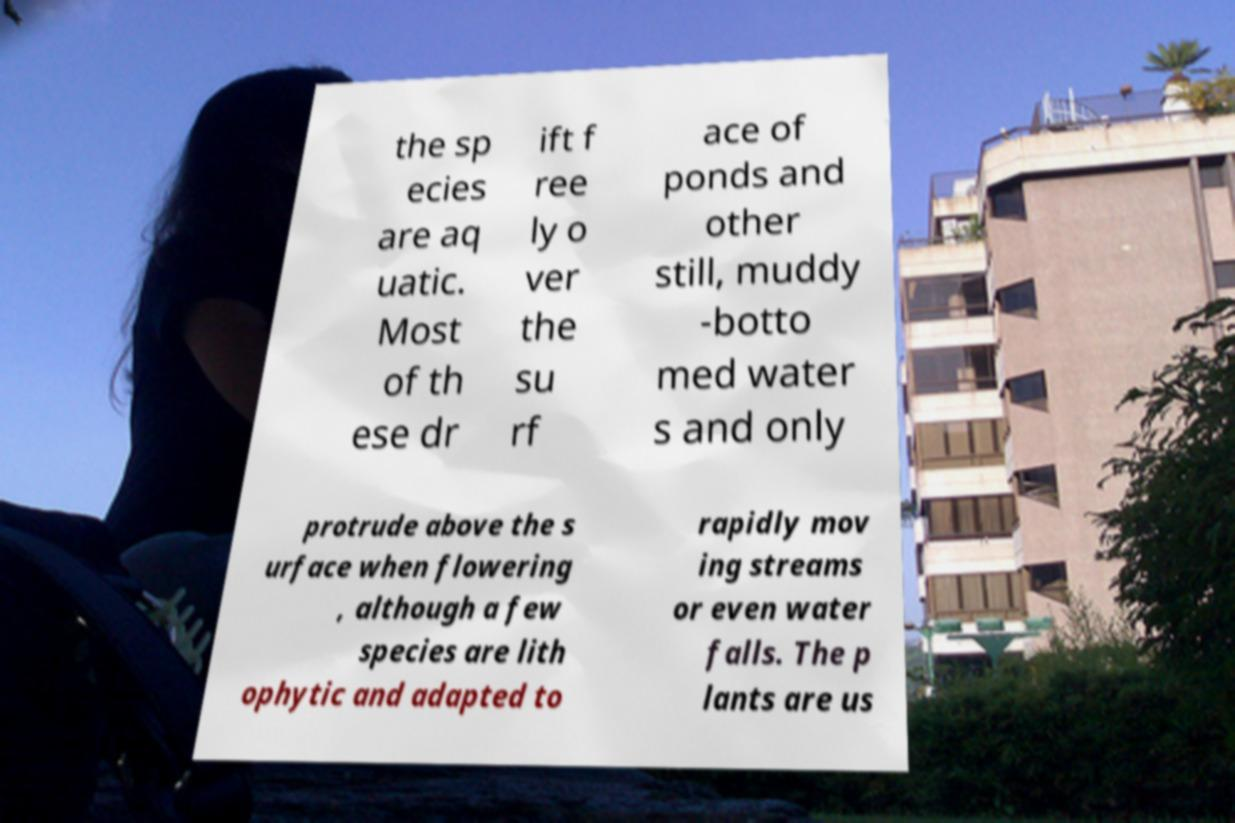I need the written content from this picture converted into text. Can you do that? the sp ecies are aq uatic. Most of th ese dr ift f ree ly o ver the su rf ace of ponds and other still, muddy -botto med water s and only protrude above the s urface when flowering , although a few species are lith ophytic and adapted to rapidly mov ing streams or even water falls. The p lants are us 